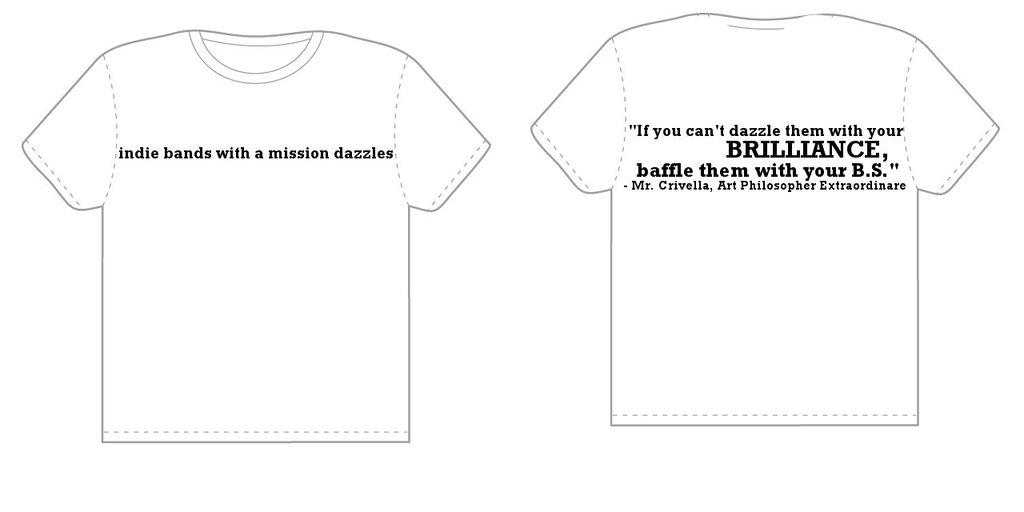Who is quoted as saying what is on this shirt?
Provide a short and direct response. Mr. crivella. What is the text in bolded capital letters?
Offer a terse response. Brilliance. 